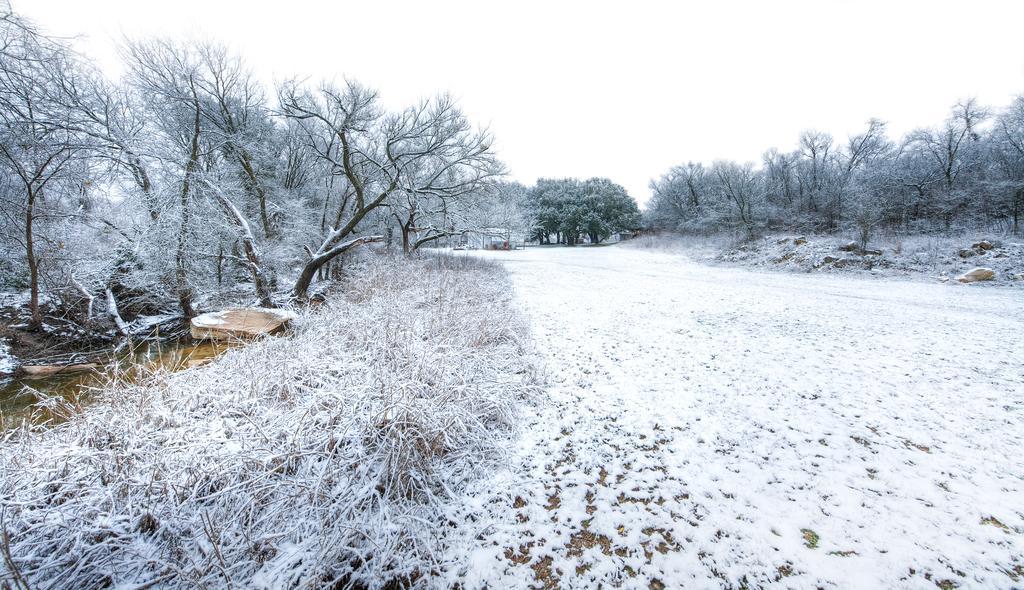Describe this image in one or two sentences. In this image, we can see snow on the ground, there are some trees, at the top there is a sky. 